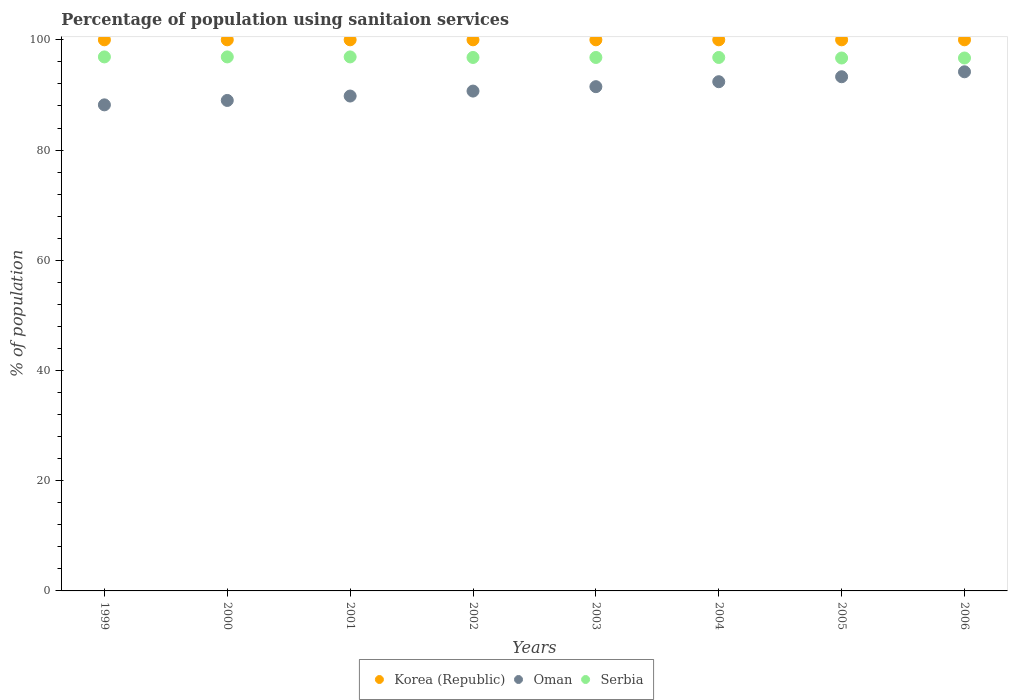How many different coloured dotlines are there?
Provide a short and direct response. 3. Is the number of dotlines equal to the number of legend labels?
Your answer should be very brief. Yes. What is the percentage of population using sanitaion services in Oman in 2002?
Offer a very short reply. 90.7. Across all years, what is the maximum percentage of population using sanitaion services in Korea (Republic)?
Your response must be concise. 100. Across all years, what is the minimum percentage of population using sanitaion services in Korea (Republic)?
Your answer should be compact. 100. In which year was the percentage of population using sanitaion services in Korea (Republic) minimum?
Keep it short and to the point. 1999. What is the total percentage of population using sanitaion services in Korea (Republic) in the graph?
Ensure brevity in your answer.  800. What is the difference between the percentage of population using sanitaion services in Serbia in 2004 and the percentage of population using sanitaion services in Oman in 2002?
Offer a terse response. 6.1. What is the average percentage of population using sanitaion services in Oman per year?
Make the answer very short. 91.14. In the year 2003, what is the difference between the percentage of population using sanitaion services in Serbia and percentage of population using sanitaion services in Oman?
Provide a succinct answer. 5.3. Is the percentage of population using sanitaion services in Oman in 1999 less than that in 2003?
Provide a short and direct response. Yes. Is the difference between the percentage of population using sanitaion services in Serbia in 2001 and 2005 greater than the difference between the percentage of population using sanitaion services in Oman in 2001 and 2005?
Ensure brevity in your answer.  Yes. What is the difference between the highest and the second highest percentage of population using sanitaion services in Oman?
Provide a short and direct response. 0.9. Is the sum of the percentage of population using sanitaion services in Oman in 2001 and 2003 greater than the maximum percentage of population using sanitaion services in Korea (Republic) across all years?
Give a very brief answer. Yes. Is it the case that in every year, the sum of the percentage of population using sanitaion services in Oman and percentage of population using sanitaion services in Serbia  is greater than the percentage of population using sanitaion services in Korea (Republic)?
Ensure brevity in your answer.  Yes. Does the percentage of population using sanitaion services in Serbia monotonically increase over the years?
Offer a very short reply. No. How many dotlines are there?
Offer a terse response. 3. Where does the legend appear in the graph?
Offer a terse response. Bottom center. How many legend labels are there?
Keep it short and to the point. 3. How are the legend labels stacked?
Offer a terse response. Horizontal. What is the title of the graph?
Give a very brief answer. Percentage of population using sanitaion services. Does "Middle income" appear as one of the legend labels in the graph?
Offer a very short reply. No. What is the label or title of the X-axis?
Your response must be concise. Years. What is the label or title of the Y-axis?
Provide a short and direct response. % of population. What is the % of population of Oman in 1999?
Ensure brevity in your answer.  88.2. What is the % of population of Serbia in 1999?
Offer a terse response. 96.9. What is the % of population in Korea (Republic) in 2000?
Give a very brief answer. 100. What is the % of population of Oman in 2000?
Your answer should be very brief. 89. What is the % of population of Serbia in 2000?
Keep it short and to the point. 96.9. What is the % of population of Oman in 2001?
Ensure brevity in your answer.  89.8. What is the % of population of Serbia in 2001?
Give a very brief answer. 96.9. What is the % of population of Korea (Republic) in 2002?
Give a very brief answer. 100. What is the % of population in Oman in 2002?
Your response must be concise. 90.7. What is the % of population of Serbia in 2002?
Keep it short and to the point. 96.8. What is the % of population of Oman in 2003?
Your response must be concise. 91.5. What is the % of population of Serbia in 2003?
Your answer should be very brief. 96.8. What is the % of population of Korea (Republic) in 2004?
Provide a short and direct response. 100. What is the % of population of Oman in 2004?
Keep it short and to the point. 92.4. What is the % of population in Serbia in 2004?
Offer a terse response. 96.8. What is the % of population of Oman in 2005?
Your answer should be very brief. 93.3. What is the % of population of Serbia in 2005?
Offer a very short reply. 96.7. What is the % of population of Korea (Republic) in 2006?
Make the answer very short. 100. What is the % of population in Oman in 2006?
Provide a short and direct response. 94.2. What is the % of population in Serbia in 2006?
Give a very brief answer. 96.7. Across all years, what is the maximum % of population in Korea (Republic)?
Give a very brief answer. 100. Across all years, what is the maximum % of population of Oman?
Your response must be concise. 94.2. Across all years, what is the maximum % of population in Serbia?
Provide a short and direct response. 96.9. Across all years, what is the minimum % of population of Oman?
Ensure brevity in your answer.  88.2. Across all years, what is the minimum % of population in Serbia?
Your answer should be very brief. 96.7. What is the total % of population in Korea (Republic) in the graph?
Your answer should be compact. 800. What is the total % of population in Oman in the graph?
Keep it short and to the point. 729.1. What is the total % of population in Serbia in the graph?
Your response must be concise. 774.5. What is the difference between the % of population of Korea (Republic) in 1999 and that in 2000?
Provide a succinct answer. 0. What is the difference between the % of population of Korea (Republic) in 1999 and that in 2001?
Your response must be concise. 0. What is the difference between the % of population in Oman in 1999 and that in 2001?
Provide a succinct answer. -1.6. What is the difference between the % of population of Serbia in 1999 and that in 2001?
Make the answer very short. 0. What is the difference between the % of population in Oman in 1999 and that in 2002?
Make the answer very short. -2.5. What is the difference between the % of population in Serbia in 1999 and that in 2002?
Your answer should be compact. 0.1. What is the difference between the % of population of Korea (Republic) in 1999 and that in 2003?
Ensure brevity in your answer.  0. What is the difference between the % of population of Oman in 1999 and that in 2003?
Give a very brief answer. -3.3. What is the difference between the % of population in Serbia in 1999 and that in 2003?
Ensure brevity in your answer.  0.1. What is the difference between the % of population of Oman in 1999 and that in 2004?
Your answer should be compact. -4.2. What is the difference between the % of population in Korea (Republic) in 1999 and that in 2005?
Your answer should be very brief. 0. What is the difference between the % of population of Serbia in 1999 and that in 2005?
Offer a very short reply. 0.2. What is the difference between the % of population of Korea (Republic) in 2000 and that in 2001?
Offer a very short reply. 0. What is the difference between the % of population of Serbia in 2000 and that in 2001?
Provide a succinct answer. 0. What is the difference between the % of population of Korea (Republic) in 2000 and that in 2002?
Give a very brief answer. 0. What is the difference between the % of population of Oman in 2000 and that in 2002?
Offer a very short reply. -1.7. What is the difference between the % of population of Korea (Republic) in 2000 and that in 2003?
Give a very brief answer. 0. What is the difference between the % of population of Oman in 2000 and that in 2003?
Your answer should be compact. -2.5. What is the difference between the % of population of Korea (Republic) in 2000 and that in 2004?
Your answer should be very brief. 0. What is the difference between the % of population of Serbia in 2000 and that in 2004?
Give a very brief answer. 0.1. What is the difference between the % of population of Oman in 2000 and that in 2005?
Your response must be concise. -4.3. What is the difference between the % of population of Serbia in 2000 and that in 2005?
Offer a very short reply. 0.2. What is the difference between the % of population in Serbia in 2000 and that in 2006?
Make the answer very short. 0.2. What is the difference between the % of population in Korea (Republic) in 2001 and that in 2002?
Your response must be concise. 0. What is the difference between the % of population of Korea (Republic) in 2001 and that in 2003?
Keep it short and to the point. 0. What is the difference between the % of population in Oman in 2001 and that in 2003?
Give a very brief answer. -1.7. What is the difference between the % of population in Serbia in 2001 and that in 2003?
Your answer should be compact. 0.1. What is the difference between the % of population in Korea (Republic) in 2001 and that in 2006?
Give a very brief answer. 0. What is the difference between the % of population of Oman in 2002 and that in 2003?
Keep it short and to the point. -0.8. What is the difference between the % of population of Serbia in 2002 and that in 2003?
Make the answer very short. 0. What is the difference between the % of population in Korea (Republic) in 2002 and that in 2004?
Your answer should be very brief. 0. What is the difference between the % of population in Oman in 2002 and that in 2005?
Ensure brevity in your answer.  -2.6. What is the difference between the % of population of Serbia in 2002 and that in 2005?
Your response must be concise. 0.1. What is the difference between the % of population of Korea (Republic) in 2002 and that in 2006?
Provide a succinct answer. 0. What is the difference between the % of population of Oman in 2002 and that in 2006?
Your answer should be very brief. -3.5. What is the difference between the % of population of Korea (Republic) in 2003 and that in 2004?
Ensure brevity in your answer.  0. What is the difference between the % of population of Serbia in 2003 and that in 2004?
Offer a very short reply. 0. What is the difference between the % of population of Korea (Republic) in 2003 and that in 2005?
Offer a very short reply. 0. What is the difference between the % of population in Serbia in 2003 and that in 2005?
Ensure brevity in your answer.  0.1. What is the difference between the % of population in Korea (Republic) in 2003 and that in 2006?
Your answer should be compact. 0. What is the difference between the % of population in Serbia in 2003 and that in 2006?
Your answer should be compact. 0.1. What is the difference between the % of population in Korea (Republic) in 2004 and that in 2005?
Keep it short and to the point. 0. What is the difference between the % of population of Oman in 2004 and that in 2005?
Your answer should be compact. -0.9. What is the difference between the % of population of Serbia in 2004 and that in 2005?
Your answer should be very brief. 0.1. What is the difference between the % of population in Korea (Republic) in 2004 and that in 2006?
Provide a short and direct response. 0. What is the difference between the % of population of Oman in 2004 and that in 2006?
Your answer should be compact. -1.8. What is the difference between the % of population in Oman in 1999 and the % of population in Serbia in 2000?
Offer a terse response. -8.7. What is the difference between the % of population of Korea (Republic) in 1999 and the % of population of Oman in 2001?
Your response must be concise. 10.2. What is the difference between the % of population in Korea (Republic) in 1999 and the % of population in Serbia in 2001?
Provide a succinct answer. 3.1. What is the difference between the % of population of Korea (Republic) in 1999 and the % of population of Serbia in 2002?
Give a very brief answer. 3.2. What is the difference between the % of population of Oman in 1999 and the % of population of Serbia in 2002?
Provide a succinct answer. -8.6. What is the difference between the % of population of Korea (Republic) in 1999 and the % of population of Oman in 2005?
Your answer should be compact. 6.7. What is the difference between the % of population of Korea (Republic) in 1999 and the % of population of Serbia in 2005?
Your response must be concise. 3.3. What is the difference between the % of population of Korea (Republic) in 1999 and the % of population of Oman in 2006?
Offer a very short reply. 5.8. What is the difference between the % of population of Korea (Republic) in 1999 and the % of population of Serbia in 2006?
Your response must be concise. 3.3. What is the difference between the % of population in Oman in 1999 and the % of population in Serbia in 2006?
Keep it short and to the point. -8.5. What is the difference between the % of population in Korea (Republic) in 2000 and the % of population in Serbia in 2001?
Your response must be concise. 3.1. What is the difference between the % of population in Korea (Republic) in 2000 and the % of population in Serbia in 2002?
Your answer should be compact. 3.2. What is the difference between the % of population of Korea (Republic) in 2000 and the % of population of Oman in 2003?
Offer a very short reply. 8.5. What is the difference between the % of population in Korea (Republic) in 2000 and the % of population in Serbia in 2003?
Give a very brief answer. 3.2. What is the difference between the % of population in Korea (Republic) in 2000 and the % of population in Oman in 2004?
Make the answer very short. 7.6. What is the difference between the % of population in Korea (Republic) in 2000 and the % of population in Serbia in 2004?
Ensure brevity in your answer.  3.2. What is the difference between the % of population in Oman in 2000 and the % of population in Serbia in 2004?
Ensure brevity in your answer.  -7.8. What is the difference between the % of population in Korea (Republic) in 2000 and the % of population in Oman in 2005?
Your response must be concise. 6.7. What is the difference between the % of population of Oman in 2000 and the % of population of Serbia in 2006?
Offer a terse response. -7.7. What is the difference between the % of population of Korea (Republic) in 2001 and the % of population of Serbia in 2002?
Provide a short and direct response. 3.2. What is the difference between the % of population in Oman in 2001 and the % of population in Serbia in 2002?
Your answer should be compact. -7. What is the difference between the % of population in Oman in 2001 and the % of population in Serbia in 2003?
Offer a terse response. -7. What is the difference between the % of population of Korea (Republic) in 2001 and the % of population of Serbia in 2004?
Your answer should be very brief. 3.2. What is the difference between the % of population of Oman in 2001 and the % of population of Serbia in 2004?
Offer a very short reply. -7. What is the difference between the % of population of Korea (Republic) in 2001 and the % of population of Serbia in 2005?
Make the answer very short. 3.3. What is the difference between the % of population in Korea (Republic) in 2002 and the % of population in Oman in 2003?
Give a very brief answer. 8.5. What is the difference between the % of population of Korea (Republic) in 2002 and the % of population of Serbia in 2003?
Your answer should be compact. 3.2. What is the difference between the % of population of Korea (Republic) in 2002 and the % of population of Serbia in 2004?
Keep it short and to the point. 3.2. What is the difference between the % of population of Oman in 2002 and the % of population of Serbia in 2004?
Your response must be concise. -6.1. What is the difference between the % of population of Korea (Republic) in 2002 and the % of population of Serbia in 2006?
Offer a terse response. 3.3. What is the difference between the % of population in Korea (Republic) in 2003 and the % of population in Oman in 2004?
Offer a very short reply. 7.6. What is the difference between the % of population of Korea (Republic) in 2003 and the % of population of Serbia in 2004?
Offer a terse response. 3.2. What is the difference between the % of population of Korea (Republic) in 2003 and the % of population of Serbia in 2005?
Make the answer very short. 3.3. What is the difference between the % of population in Korea (Republic) in 2003 and the % of population in Oman in 2006?
Provide a short and direct response. 5.8. What is the difference between the % of population in Korea (Republic) in 2003 and the % of population in Serbia in 2006?
Ensure brevity in your answer.  3.3. What is the difference between the % of population of Oman in 2004 and the % of population of Serbia in 2006?
Provide a short and direct response. -4.3. What is the difference between the % of population in Korea (Republic) in 2005 and the % of population in Oman in 2006?
Provide a succinct answer. 5.8. What is the average % of population in Korea (Republic) per year?
Offer a very short reply. 100. What is the average % of population in Oman per year?
Offer a terse response. 91.14. What is the average % of population of Serbia per year?
Keep it short and to the point. 96.81. In the year 1999, what is the difference between the % of population of Korea (Republic) and % of population of Oman?
Offer a very short reply. 11.8. In the year 1999, what is the difference between the % of population in Korea (Republic) and % of population in Serbia?
Offer a very short reply. 3.1. In the year 2000, what is the difference between the % of population in Korea (Republic) and % of population in Serbia?
Your response must be concise. 3.1. In the year 2000, what is the difference between the % of population in Oman and % of population in Serbia?
Your response must be concise. -7.9. In the year 2002, what is the difference between the % of population in Korea (Republic) and % of population in Oman?
Ensure brevity in your answer.  9.3. In the year 2002, what is the difference between the % of population in Korea (Republic) and % of population in Serbia?
Keep it short and to the point. 3.2. In the year 2003, what is the difference between the % of population of Korea (Republic) and % of population of Serbia?
Provide a succinct answer. 3.2. In the year 2003, what is the difference between the % of population in Oman and % of population in Serbia?
Offer a terse response. -5.3. In the year 2004, what is the difference between the % of population in Korea (Republic) and % of population in Serbia?
Your response must be concise. 3.2. In the year 2004, what is the difference between the % of population of Oman and % of population of Serbia?
Offer a terse response. -4.4. In the year 2005, what is the difference between the % of population of Korea (Republic) and % of population of Oman?
Make the answer very short. 6.7. In the year 2005, what is the difference between the % of population in Korea (Republic) and % of population in Serbia?
Offer a very short reply. 3.3. In the year 2006, what is the difference between the % of population of Korea (Republic) and % of population of Oman?
Offer a very short reply. 5.8. In the year 2006, what is the difference between the % of population in Korea (Republic) and % of population in Serbia?
Your answer should be very brief. 3.3. In the year 2006, what is the difference between the % of population of Oman and % of population of Serbia?
Give a very brief answer. -2.5. What is the ratio of the % of population of Korea (Republic) in 1999 to that in 2000?
Give a very brief answer. 1. What is the ratio of the % of population in Serbia in 1999 to that in 2000?
Your answer should be very brief. 1. What is the ratio of the % of population in Oman in 1999 to that in 2001?
Make the answer very short. 0.98. What is the ratio of the % of population of Oman in 1999 to that in 2002?
Offer a very short reply. 0.97. What is the ratio of the % of population of Korea (Republic) in 1999 to that in 2003?
Your answer should be very brief. 1. What is the ratio of the % of population in Oman in 1999 to that in 2003?
Your response must be concise. 0.96. What is the ratio of the % of population of Serbia in 1999 to that in 2003?
Your answer should be very brief. 1. What is the ratio of the % of population in Oman in 1999 to that in 2004?
Your answer should be very brief. 0.95. What is the ratio of the % of population in Serbia in 1999 to that in 2004?
Give a very brief answer. 1. What is the ratio of the % of population of Oman in 1999 to that in 2005?
Offer a terse response. 0.95. What is the ratio of the % of population in Korea (Republic) in 1999 to that in 2006?
Keep it short and to the point. 1. What is the ratio of the % of population of Oman in 1999 to that in 2006?
Give a very brief answer. 0.94. What is the ratio of the % of population of Korea (Republic) in 2000 to that in 2002?
Ensure brevity in your answer.  1. What is the ratio of the % of population of Oman in 2000 to that in 2002?
Your answer should be compact. 0.98. What is the ratio of the % of population in Serbia in 2000 to that in 2002?
Provide a succinct answer. 1. What is the ratio of the % of population of Oman in 2000 to that in 2003?
Offer a terse response. 0.97. What is the ratio of the % of population of Oman in 2000 to that in 2004?
Your answer should be compact. 0.96. What is the ratio of the % of population of Oman in 2000 to that in 2005?
Ensure brevity in your answer.  0.95. What is the ratio of the % of population of Serbia in 2000 to that in 2005?
Ensure brevity in your answer.  1. What is the ratio of the % of population in Oman in 2000 to that in 2006?
Give a very brief answer. 0.94. What is the ratio of the % of population in Serbia in 2000 to that in 2006?
Keep it short and to the point. 1. What is the ratio of the % of population in Oman in 2001 to that in 2002?
Offer a very short reply. 0.99. What is the ratio of the % of population in Serbia in 2001 to that in 2002?
Your answer should be very brief. 1. What is the ratio of the % of population in Oman in 2001 to that in 2003?
Ensure brevity in your answer.  0.98. What is the ratio of the % of population in Serbia in 2001 to that in 2003?
Offer a very short reply. 1. What is the ratio of the % of population of Korea (Republic) in 2001 to that in 2004?
Keep it short and to the point. 1. What is the ratio of the % of population in Oman in 2001 to that in 2004?
Give a very brief answer. 0.97. What is the ratio of the % of population of Oman in 2001 to that in 2005?
Make the answer very short. 0.96. What is the ratio of the % of population in Oman in 2001 to that in 2006?
Offer a very short reply. 0.95. What is the ratio of the % of population of Serbia in 2001 to that in 2006?
Offer a very short reply. 1. What is the ratio of the % of population of Korea (Republic) in 2002 to that in 2003?
Ensure brevity in your answer.  1. What is the ratio of the % of population of Oman in 2002 to that in 2003?
Offer a very short reply. 0.99. What is the ratio of the % of population of Korea (Republic) in 2002 to that in 2004?
Keep it short and to the point. 1. What is the ratio of the % of population of Oman in 2002 to that in 2004?
Offer a terse response. 0.98. What is the ratio of the % of population in Korea (Republic) in 2002 to that in 2005?
Give a very brief answer. 1. What is the ratio of the % of population in Oman in 2002 to that in 2005?
Provide a short and direct response. 0.97. What is the ratio of the % of population in Serbia in 2002 to that in 2005?
Your answer should be very brief. 1. What is the ratio of the % of population of Korea (Republic) in 2002 to that in 2006?
Your answer should be compact. 1. What is the ratio of the % of population in Oman in 2002 to that in 2006?
Ensure brevity in your answer.  0.96. What is the ratio of the % of population in Korea (Republic) in 2003 to that in 2004?
Ensure brevity in your answer.  1. What is the ratio of the % of population of Oman in 2003 to that in 2004?
Your answer should be compact. 0.99. What is the ratio of the % of population of Serbia in 2003 to that in 2004?
Your answer should be very brief. 1. What is the ratio of the % of population in Oman in 2003 to that in 2005?
Your answer should be compact. 0.98. What is the ratio of the % of population of Serbia in 2003 to that in 2005?
Provide a short and direct response. 1. What is the ratio of the % of population of Oman in 2003 to that in 2006?
Your answer should be compact. 0.97. What is the ratio of the % of population in Korea (Republic) in 2004 to that in 2005?
Your answer should be compact. 1. What is the ratio of the % of population in Oman in 2004 to that in 2005?
Make the answer very short. 0.99. What is the ratio of the % of population of Serbia in 2004 to that in 2005?
Offer a very short reply. 1. What is the ratio of the % of population of Oman in 2004 to that in 2006?
Make the answer very short. 0.98. What is the difference between the highest and the second highest % of population in Korea (Republic)?
Give a very brief answer. 0. What is the difference between the highest and the second highest % of population of Serbia?
Provide a short and direct response. 0. 